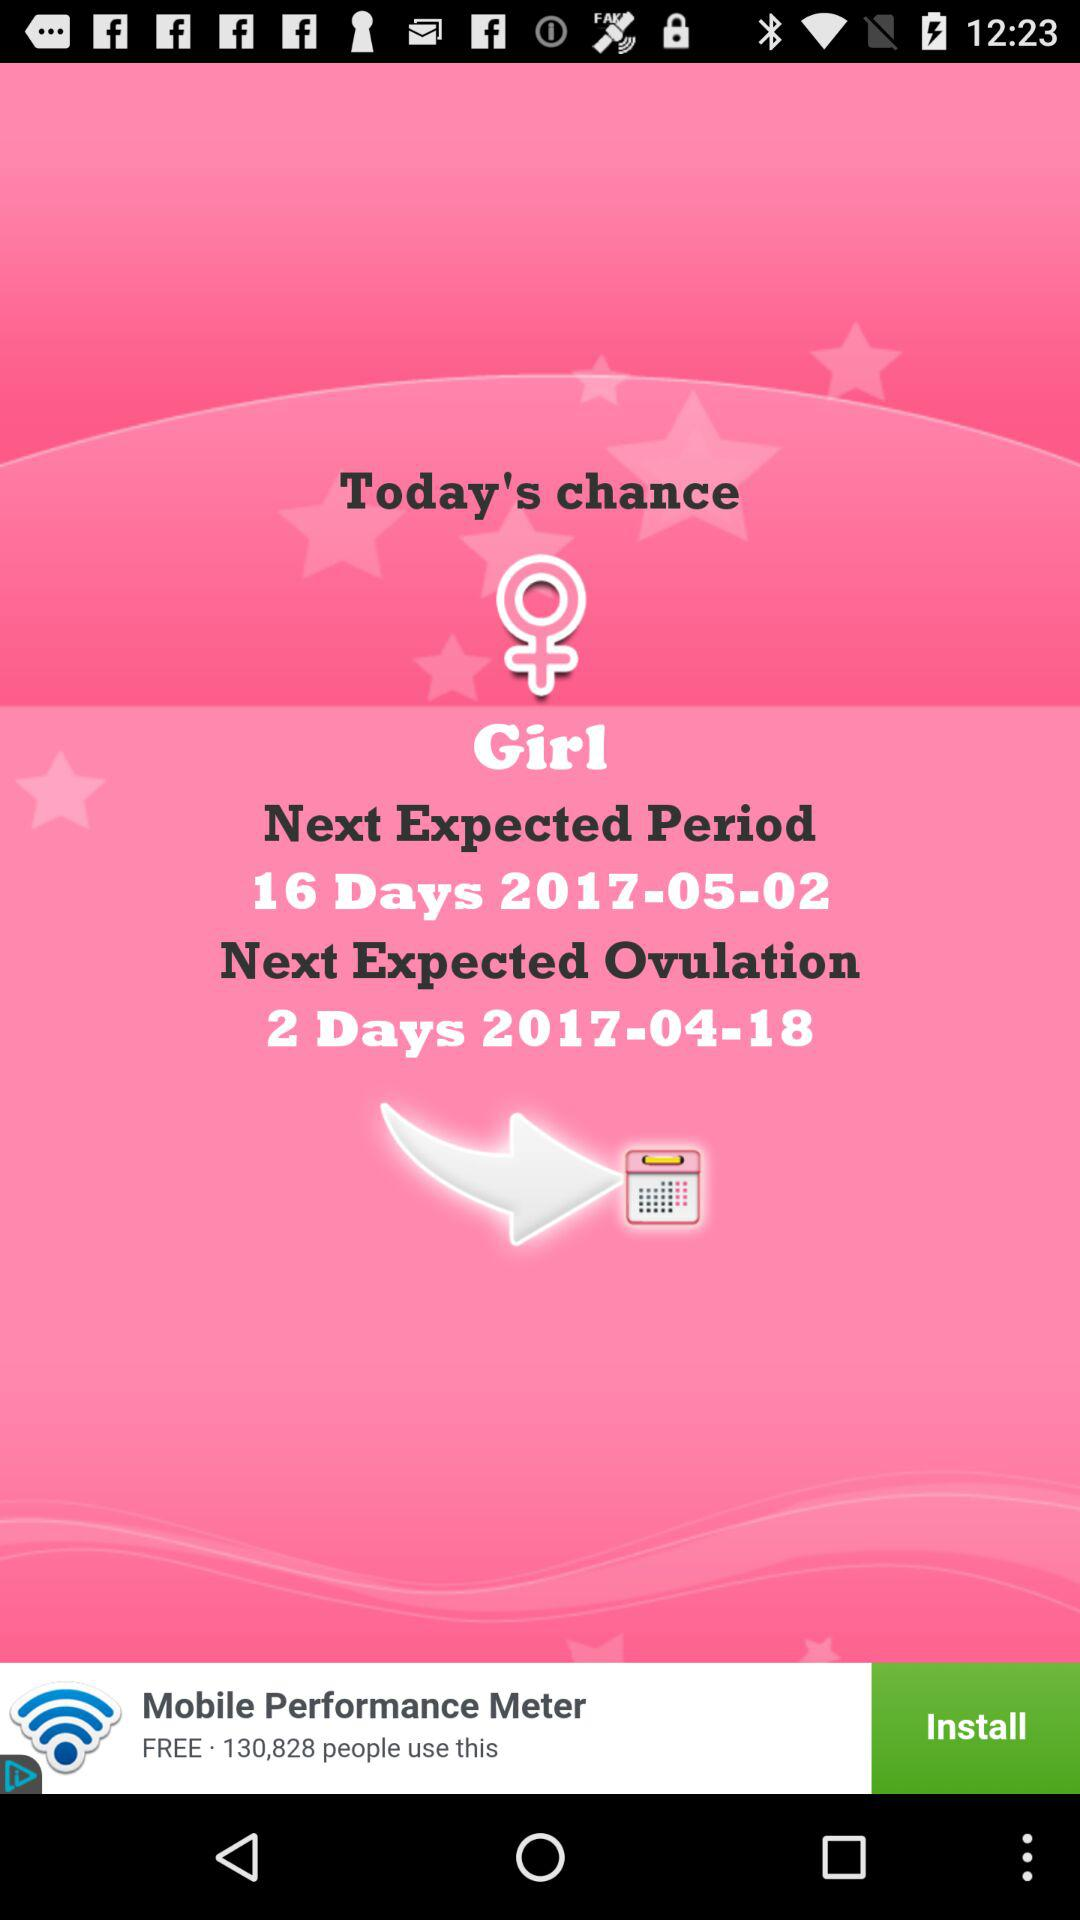When will the next expected ovulation be? The next expected ovulation will be in 2 days, on April 18, 2017. 